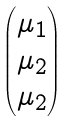<formula> <loc_0><loc_0><loc_500><loc_500>\begin{pmatrix} \mu _ { 1 } \\ \mu _ { 2 } \\ \mu _ { 2 } \end{pmatrix}</formula> 